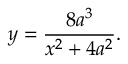<formula> <loc_0><loc_0><loc_500><loc_500>y = { \frac { 8 a ^ { 3 } } { x ^ { 2 } + 4 a ^ { 2 } } } .</formula> 